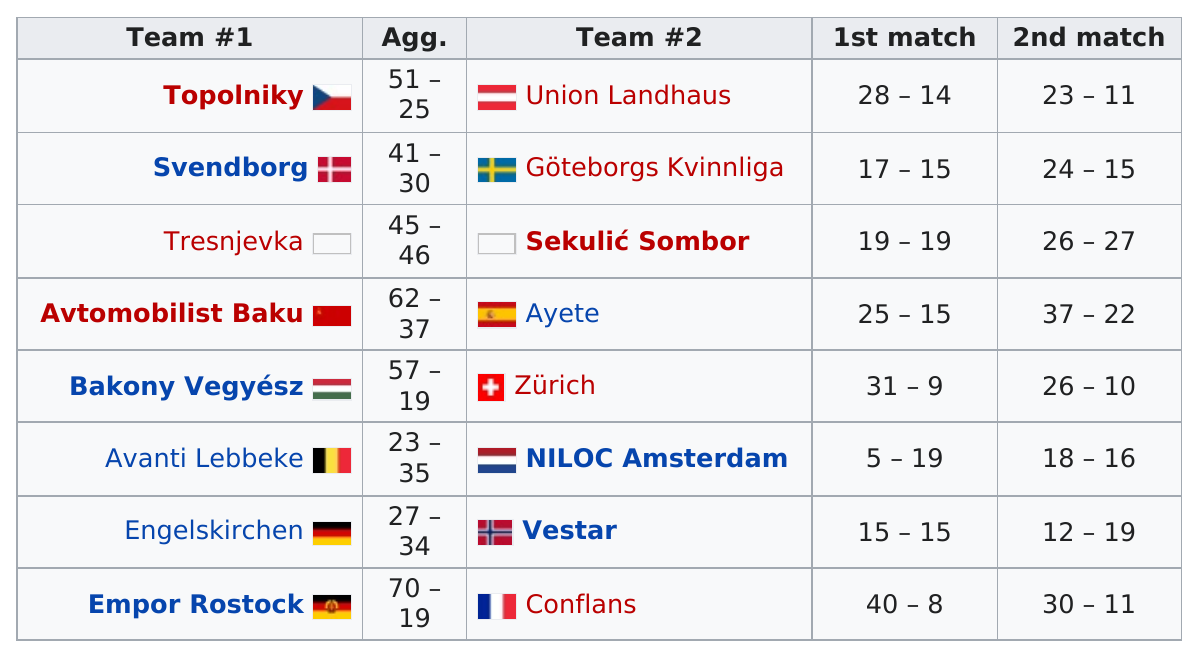Point out several critical features in this image. There are a total of 16 teams. The highest combined score in the last game on the list was achieved in the first match. During the match in which Tresnjevka scored the same number of points as Sekuli&#263; Sombor, the latter scored more points than the former. Bakony Vegyész was the first team to score over 30 points in the first match. The total amount of points scored between Topolniky and Union Landhaus in the first match was 42. 